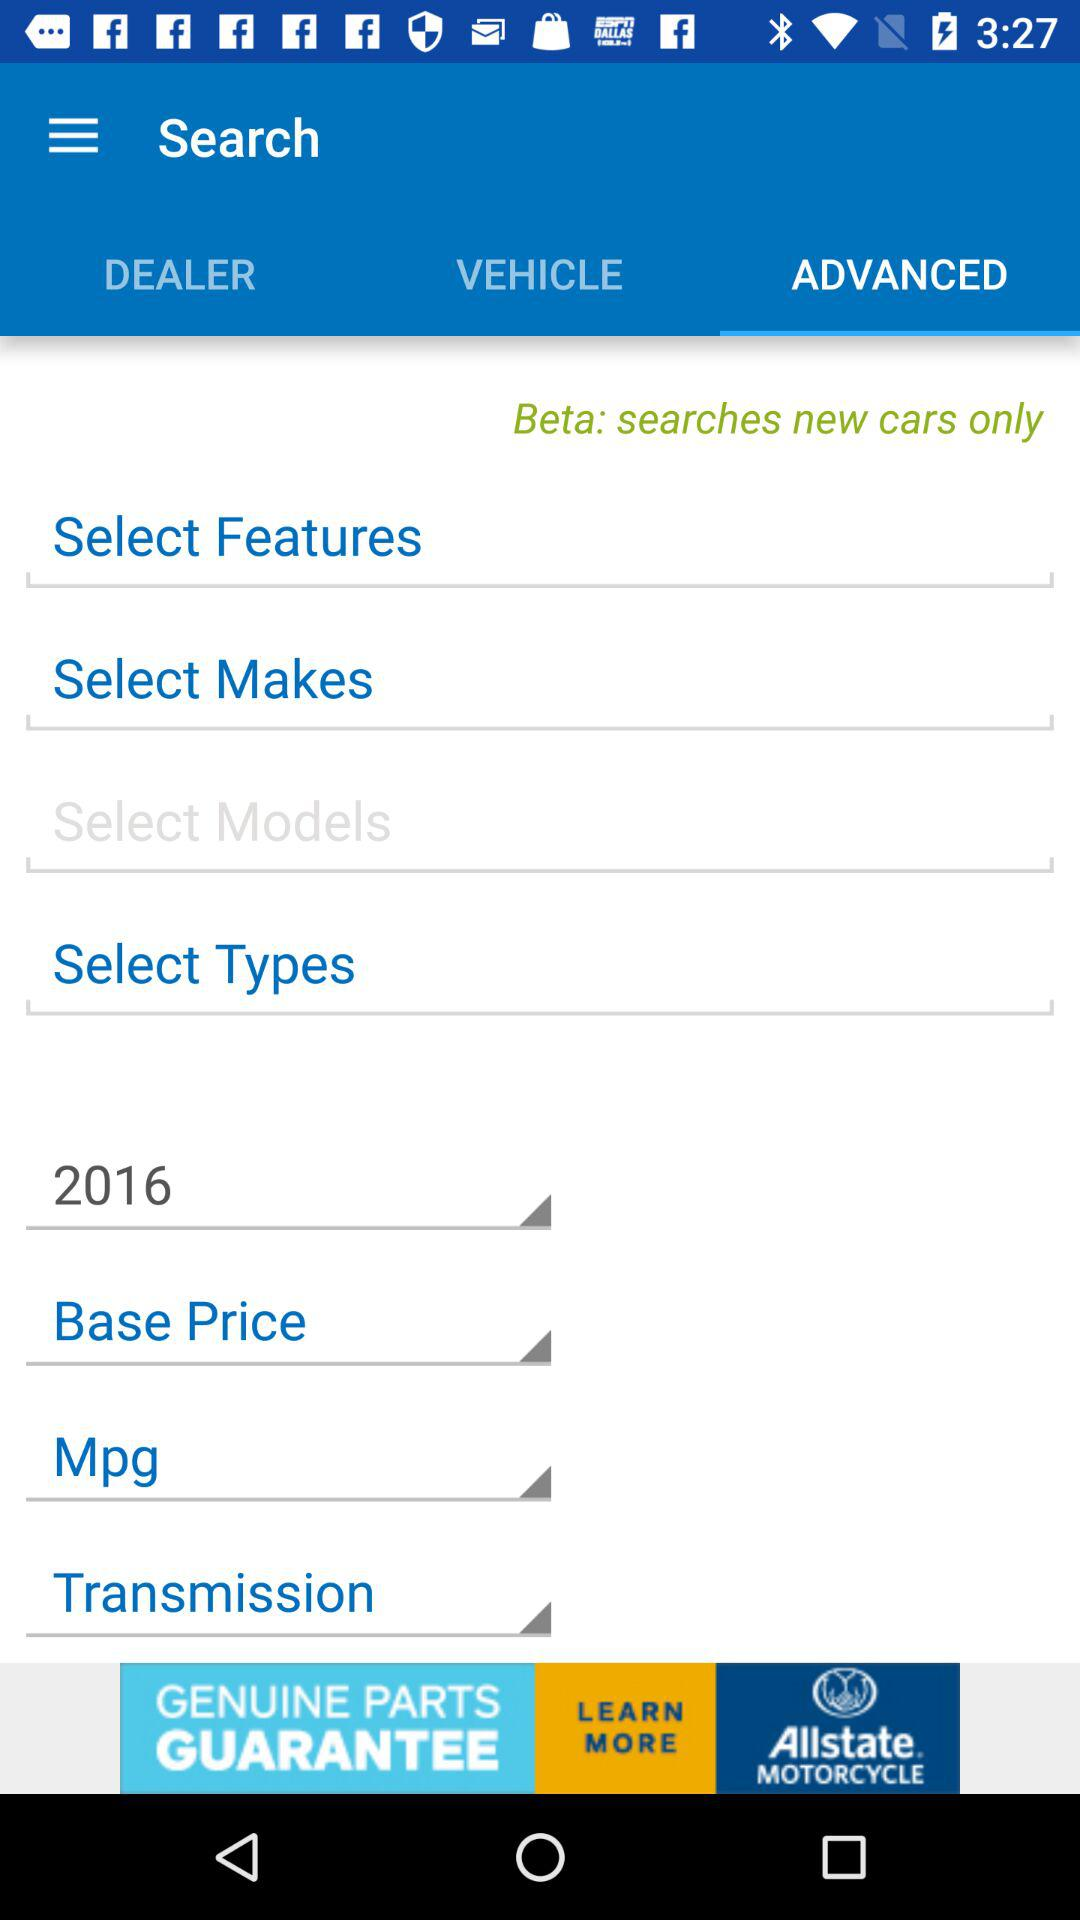Which year is selected? The selected year is 2016. 